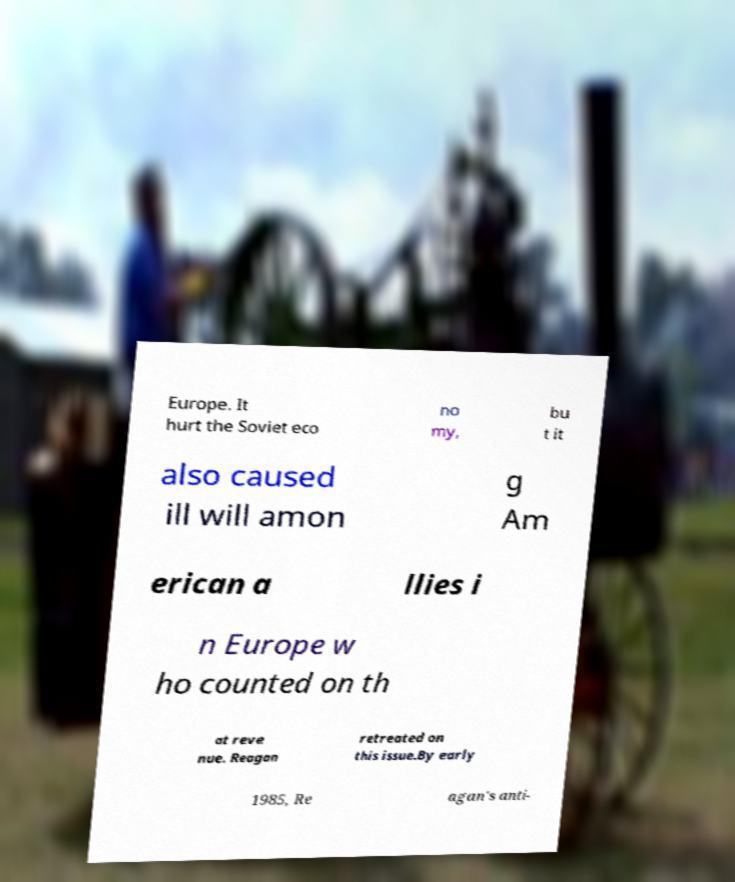I need the written content from this picture converted into text. Can you do that? Europe. It hurt the Soviet eco no my, bu t it also caused ill will amon g Am erican a llies i n Europe w ho counted on th at reve nue. Reagan retreated on this issue.By early 1985, Re agan's anti- 